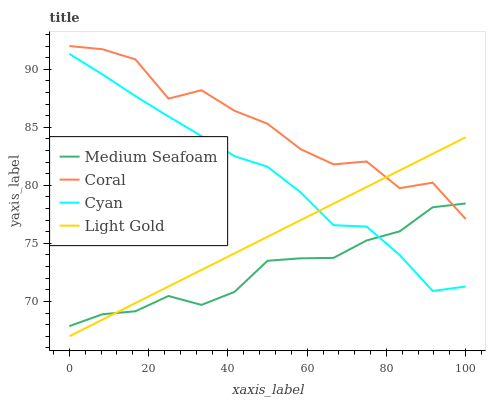Does Medium Seafoam have the minimum area under the curve?
Answer yes or no. Yes. Does Coral have the maximum area under the curve?
Answer yes or no. Yes. Does Light Gold have the minimum area under the curve?
Answer yes or no. No. Does Light Gold have the maximum area under the curve?
Answer yes or no. No. Is Light Gold the smoothest?
Answer yes or no. Yes. Is Coral the roughest?
Answer yes or no. Yes. Is Coral the smoothest?
Answer yes or no. No. Is Light Gold the roughest?
Answer yes or no. No. Does Light Gold have the lowest value?
Answer yes or no. Yes. Does Coral have the lowest value?
Answer yes or no. No. Does Coral have the highest value?
Answer yes or no. Yes. Does Light Gold have the highest value?
Answer yes or no. No. Is Cyan less than Coral?
Answer yes or no. Yes. Is Coral greater than Cyan?
Answer yes or no. Yes. Does Medium Seafoam intersect Light Gold?
Answer yes or no. Yes. Is Medium Seafoam less than Light Gold?
Answer yes or no. No. Is Medium Seafoam greater than Light Gold?
Answer yes or no. No. Does Cyan intersect Coral?
Answer yes or no. No. 